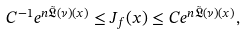<formula> <loc_0><loc_0><loc_500><loc_500>C ^ { - 1 } e ^ { n \mathfrak { \tilde { L } } ( \nu ) ( x ) } \leq J _ { f } ( x ) \leq C e ^ { n \mathfrak { \tilde { L } } ( \nu ) ( x ) } ,</formula> 